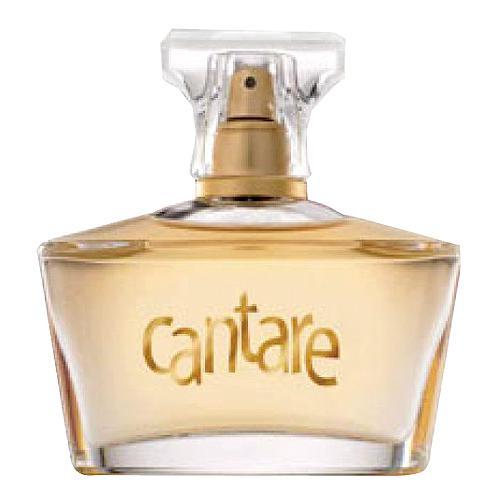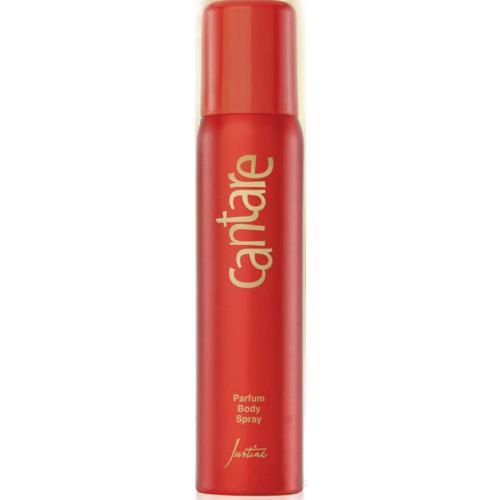The first image is the image on the left, the second image is the image on the right. Given the left and right images, does the statement "The right image contains a slender perfume container that is predominately red." hold true? Answer yes or no. Yes. The first image is the image on the left, the second image is the image on the right. For the images displayed, is the sentence "there is at least one perfume bottle with a clear cap" factually correct? Answer yes or no. Yes. 